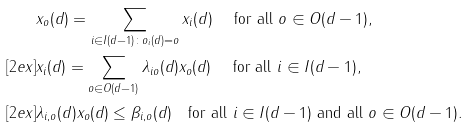<formula> <loc_0><loc_0><loc_500><loc_500>& x _ { o } ( d ) = \sum _ { i \in I ( d - 1 ) \colon o _ { i } ( d ) = o } x _ { i } ( d ) \quad \text { for all } o \in O ( d - 1 ) , \\ [ 2 e x ] & x _ { i } ( d ) = \sum _ { o \in O ( d - 1 ) } \lambda _ { i o } ( d ) x _ { o } ( d ) \quad \text { for all } i \in I ( d - 1 ) , \\ [ 2 e x ] & \lambda _ { i , o } ( d ) x _ { o } ( d ) \leq \beta _ { i , o } ( d ) \quad \text {for all } i \in I ( d - 1 ) \text { and all } o \in O ( d - 1 ) .</formula> 